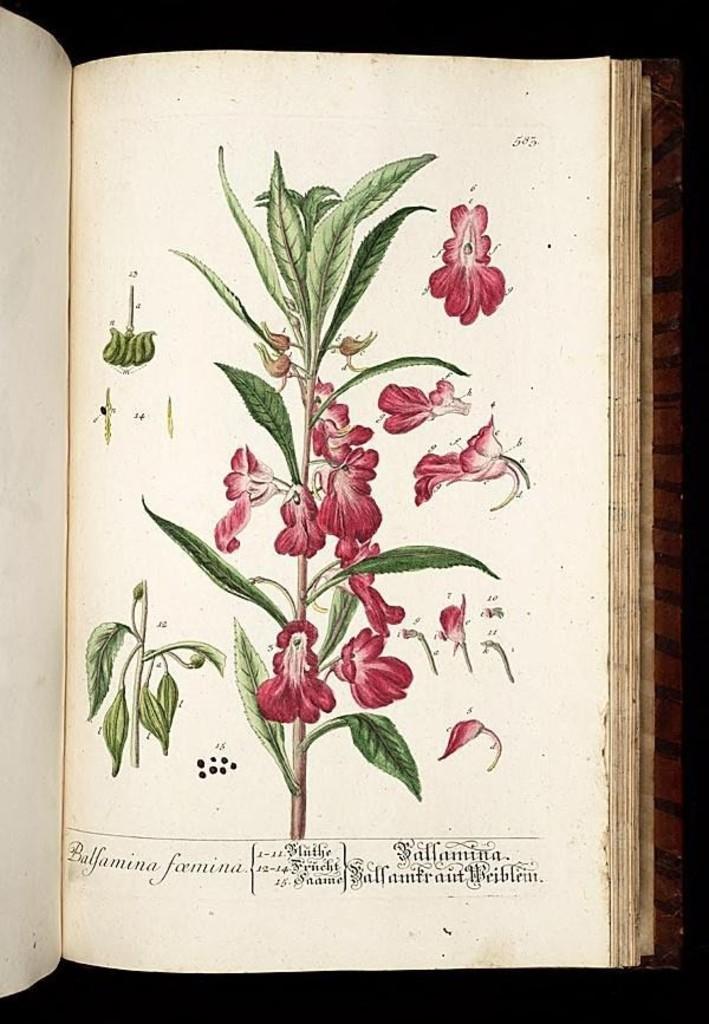Could you give a brief overview of what you see in this image? In the center of the image there is a book placed on the table. 